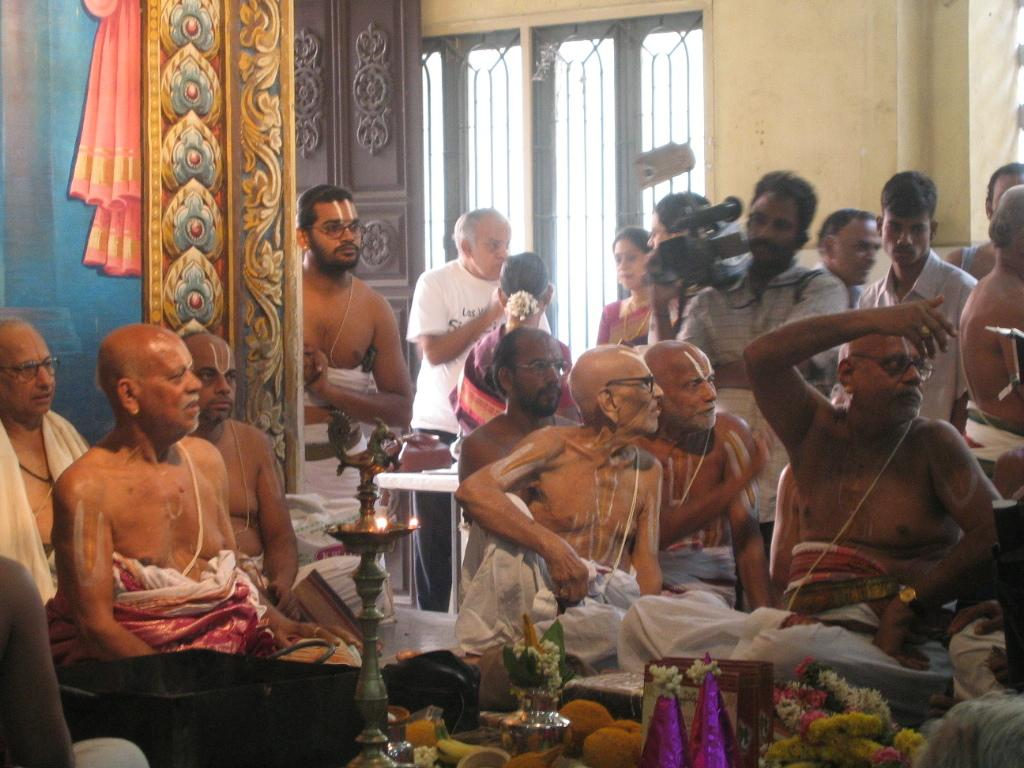What are the people in the image doing? There are people seated and standing in the image. Can you describe the man holding an object in his hand? There is a man standing and holding a video camera in his hand. What type of whip is being used by the person in the image? There is no whip present in the image; the man is holding a video camera. 